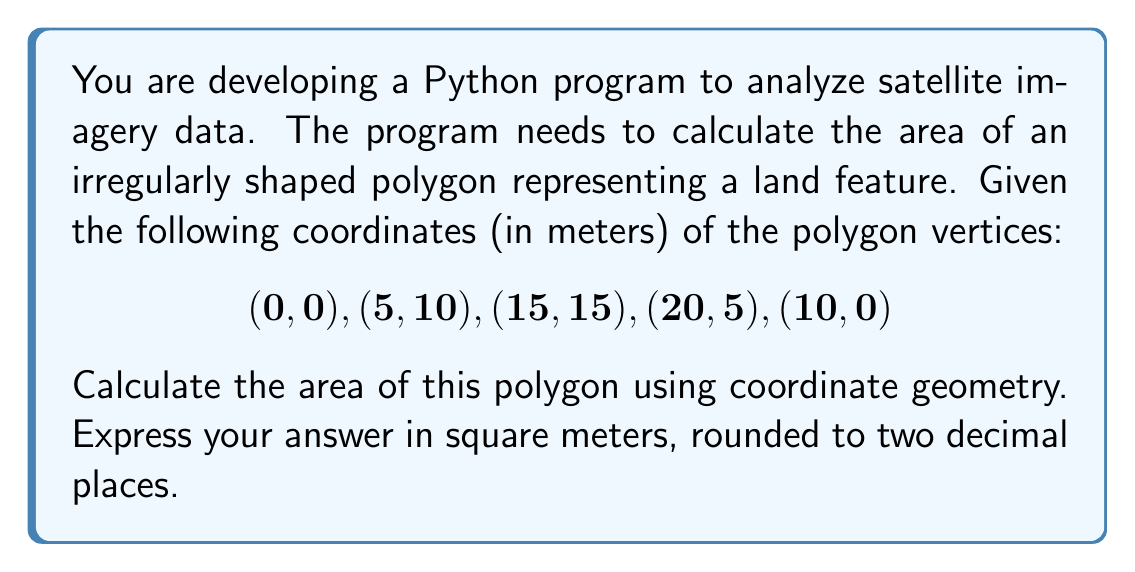Could you help me with this problem? To calculate the area of a complex polygon using coordinate geometry, we can use the Shoelace formula (also known as the surveyor's formula). This method is particularly useful for polygons with vertices given in Cartesian coordinates.

The formula is:

$$ A = \frac{1}{2}\left|\sum_{i=1}^{n-1} (x_iy_{i+1} - x_{i+1}y_i) + (x_ny_1 - x_1y_n)\right| $$

Where $(x_i, y_i)$ are the coordinates of the $i$-th vertex, and $n$ is the number of vertices.

Let's apply this formula to our polygon:

1) First, let's list our vertices in order:
   $(x_1, y_1) = (0, 0)$
   $(x_2, y_2) = (5, 10)$
   $(x_3, y_3) = (15, 15)$
   $(x_4, y_4) = (20, 5)$
   $(x_5, y_5) = (10, 0)$

2) Now, let's calculate each term in the sum:
   $(x_1y_2 - x_2y_1) = 0 \cdot 10 - 5 \cdot 0 = 0$
   $(x_2y_3 - x_3y_2) = 5 \cdot 15 - 15 \cdot 10 = -75$
   $(x_3y_4 - x_4y_3) = 15 \cdot 5 - 20 \cdot 15 = -225$
   $(x_4y_5 - x_5y_4) = 20 \cdot 0 - 10 \cdot 5 = -50$
   $(x_5y_1 - x_1y_5) = 10 \cdot 0 - 0 \cdot 0 = 0$

3) Sum these terms:
   $0 + (-75) + (-225) + (-50) + 0 = -350$

4) Take the absolute value and divide by 2:
   $\frac{1}{2}|-350| = 175$

Therefore, the area of the polygon is 175 square meters.

In Python, you could implement this calculation using Unicode characters for mathematical symbols, demonstrating your proficiency in encoding and decoding Unicode:

```python
coords = [(0, 0), (5, 10), (15, 15), (20, 5), (10, 0)]
area = 0.5 * abs(sum(x0*y1 - x1*y0 for (x0, y0), (x1, y1) in zip(coords, coords[1:] + coords[:1])))
print(f"Area: {area:.2f} m\u00B2")  # Using Unicode for superscript 2
```
Answer: 175.00 m² 